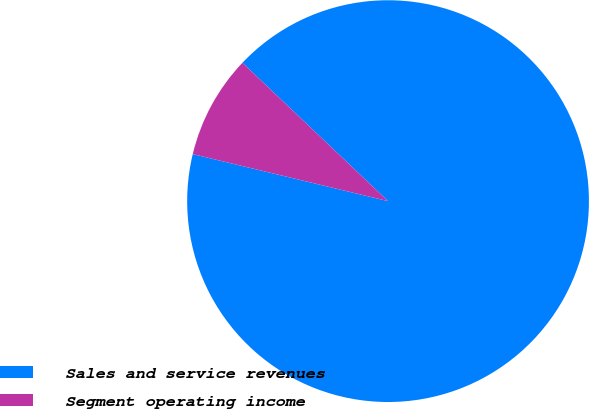Convert chart to OTSL. <chart><loc_0><loc_0><loc_500><loc_500><pie_chart><fcel>Sales and service revenues<fcel>Segment operating income<nl><fcel>91.67%<fcel>8.33%<nl></chart> 